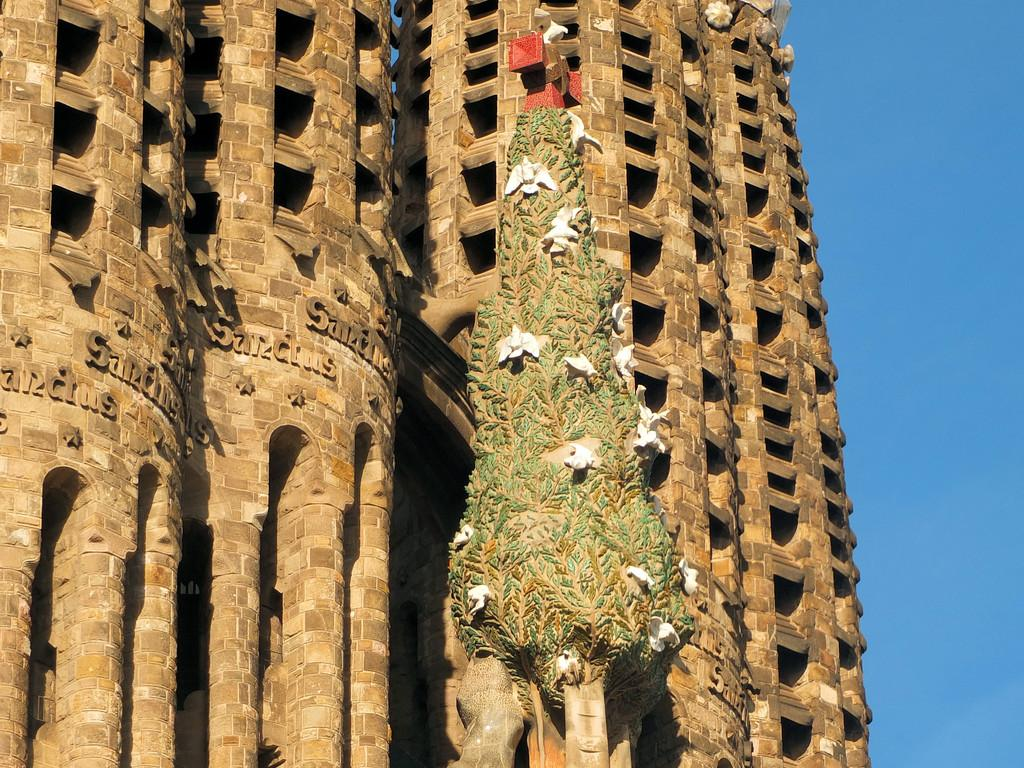What type of structure can be seen in the image? There is a building in the image. What else is present in the image besides the building? There is a tree structure with birds in the image. What can be seen in the background of the image? The sky is visible in the background of the image. What type of boundary is present in the image? There is no boundary mentioned or visible in the image. Who is the writer of the birds in the image? The image does not depict any writing or authors; it simply shows birds in a tree structure. 